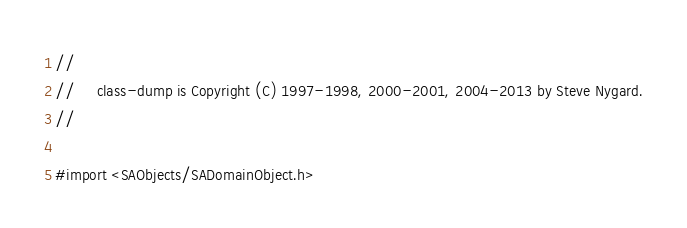<code> <loc_0><loc_0><loc_500><loc_500><_C_>//
//     class-dump is Copyright (C) 1997-1998, 2000-2001, 2004-2013 by Steve Nygard.
//

#import <SAObjects/SADomainObject.h>
</code> 